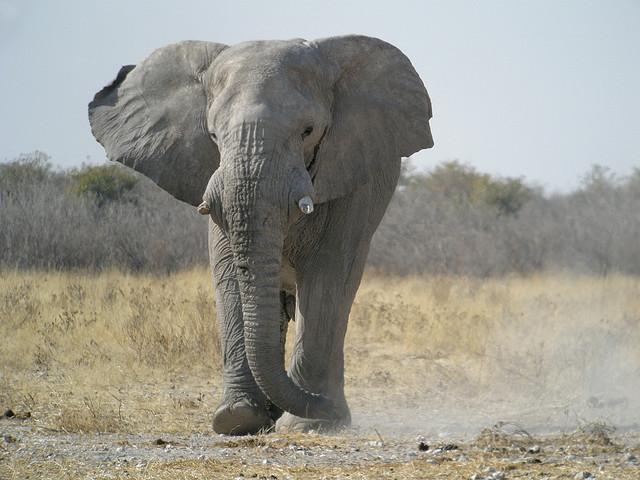What type of animal is in the photograph?
Be succinct. Elephant. What color is the grass?
Quick response, please. Brown. Does the elephants have hoofs?
Write a very short answer. No. How many elephants are shown?
Be succinct. 1. Is this a wild elephant?
Write a very short answer. Yes. Is the elephant going down the hill?
Keep it brief. No. How many trunks?
Answer briefly. 1. What is the color on the elephant?
Answer briefly. Gray. Is the elephant's trunk down?
Keep it brief. Yes. How many tusks are in the picture?
Be succinct. 2. Does this animal have large ears?
Answer briefly. Yes. How many babies are in the picture?
Give a very brief answer. 0. Is the elephant at a zoo?
Write a very short answer. No. 